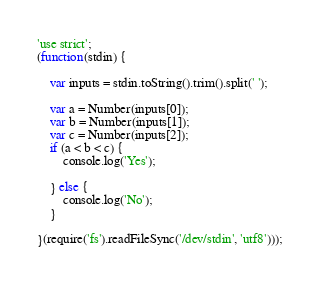Convert code to text. <code><loc_0><loc_0><loc_500><loc_500><_JavaScript_>'use strict';
(function(stdin) {

    var inputs = stdin.toString().trim().split(' ');

    var a = Number(inputs[0]);
    var b = Number(inputs[1]);
    var c = Number(inputs[2]);
    if (a < b < c) {
        console.log('Yes');

    } else {
        console.log('No');
    }

}(require('fs').readFileSync('/dev/stdin', 'utf8')));</code> 